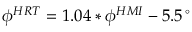Convert formula to latex. <formula><loc_0><loc_0><loc_500><loc_500>\phi ^ { H R T } = 1 . 0 4 \ast \phi ^ { H M I } - 5 . 5 \, ^ { \circ }</formula> 